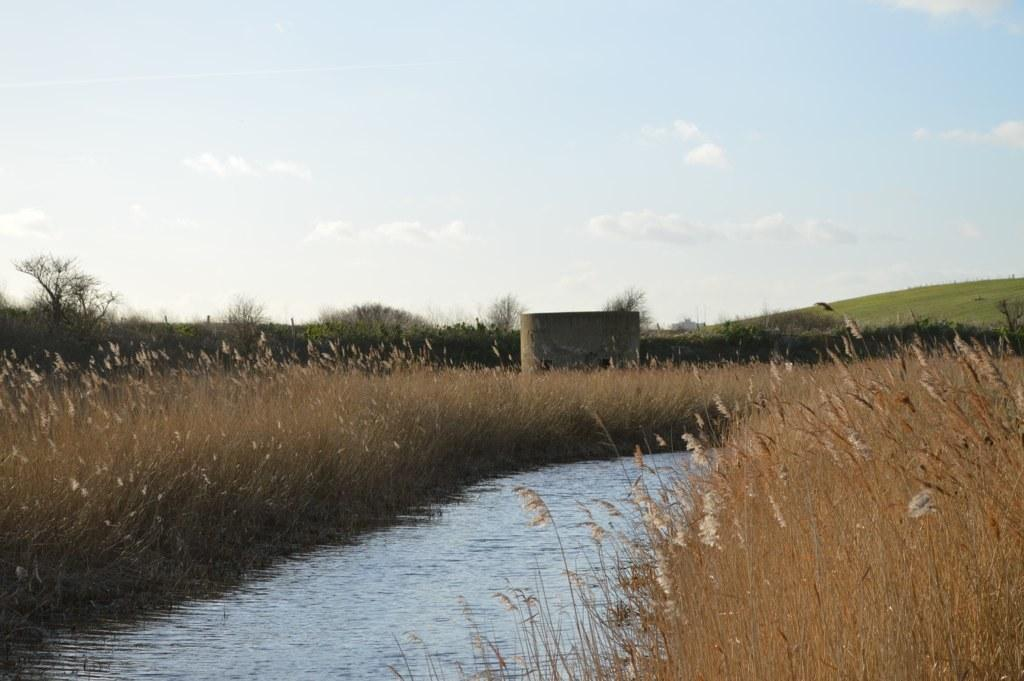What is the main feature in the center of the image? There is a canal in the center of the image. What type of vegetation can be seen in the image? There is grass visible in the image. What can be seen in the background of the image? There is a hill, trees, and the sky visible in the background of the image. What type of wine is being served on the hill in the image? There is no wine or indication of a gathering in the image; it features a canal, grass, and a hill in the background. 